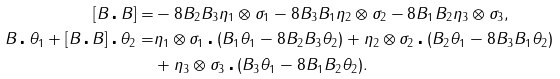<formula> <loc_0><loc_0><loc_500><loc_500>[ B \centerdot B ] = & - 8 B _ { 2 } B _ { 3 } \eta _ { 1 } \otimes \sigma _ { 1 } - 8 B _ { 3 } B _ { 1 } \eta _ { 2 } \otimes \sigma _ { 2 } - 8 B _ { 1 } B _ { 2 } \eta _ { 3 } \otimes \sigma _ { 3 } , \\ B \centerdot \theta _ { 1 } + [ B \centerdot B ] \centerdot \theta _ { 2 } = & \eta _ { 1 } \otimes \sigma _ { 1 } \centerdot ( B _ { 1 } \theta _ { 1 } - 8 B _ { 2 } B _ { 3 } \theta _ { 2 } ) + \eta _ { 2 } \otimes \sigma _ { 2 } \centerdot ( B _ { 2 } \theta _ { 1 } - 8 B _ { 3 } B _ { 1 } \theta _ { 2 } ) \\ & + \eta _ { 3 } \otimes \sigma _ { 3 } \centerdot ( B _ { 3 } \theta _ { 1 } - 8 B _ { 1 } B _ { 2 } \theta _ { 2 } ) .</formula> 